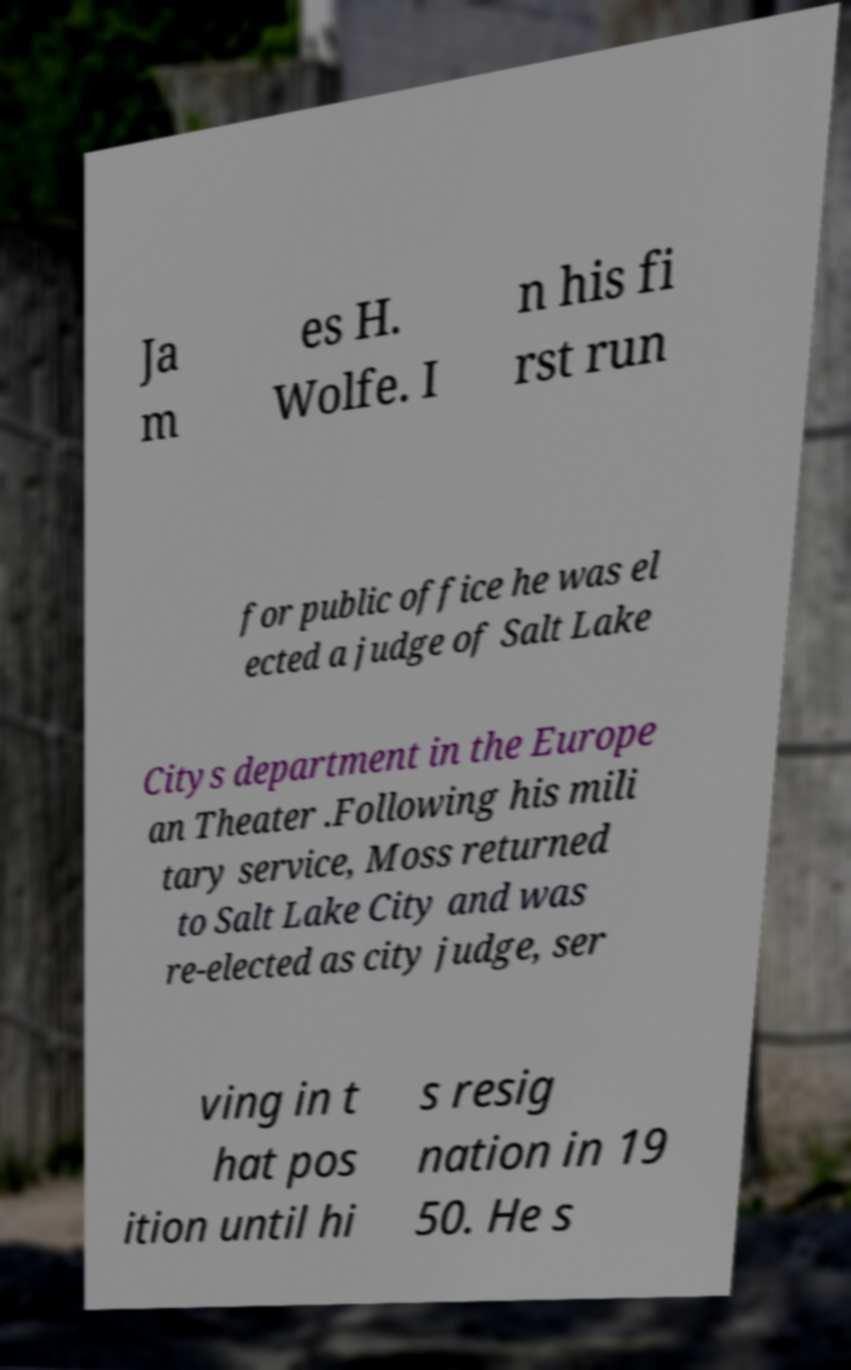Could you extract and type out the text from this image? Ja m es H. Wolfe. I n his fi rst run for public office he was el ected a judge of Salt Lake Citys department in the Europe an Theater .Following his mili tary service, Moss returned to Salt Lake City and was re-elected as city judge, ser ving in t hat pos ition until hi s resig nation in 19 50. He s 